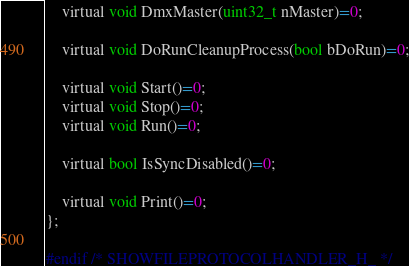Convert code to text. <code><loc_0><loc_0><loc_500><loc_500><_C_>	virtual void DmxMaster(uint32_t nMaster)=0;

	virtual void DoRunCleanupProcess(bool bDoRun)=0;

	virtual void Start()=0;
	virtual void Stop()=0;
	virtual void Run()=0;

	virtual bool IsSyncDisabled()=0;

	virtual void Print()=0;
};

#endif /* SHOWFILEPROTOCOLHANDLER_H_ */
</code> 